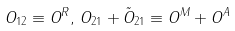Convert formula to latex. <formula><loc_0><loc_0><loc_500><loc_500>O _ { 1 2 } \equiv O ^ { R } , \, O _ { 2 1 } + \tilde { O } _ { 2 1 } \equiv O ^ { M } + O ^ { A }</formula> 